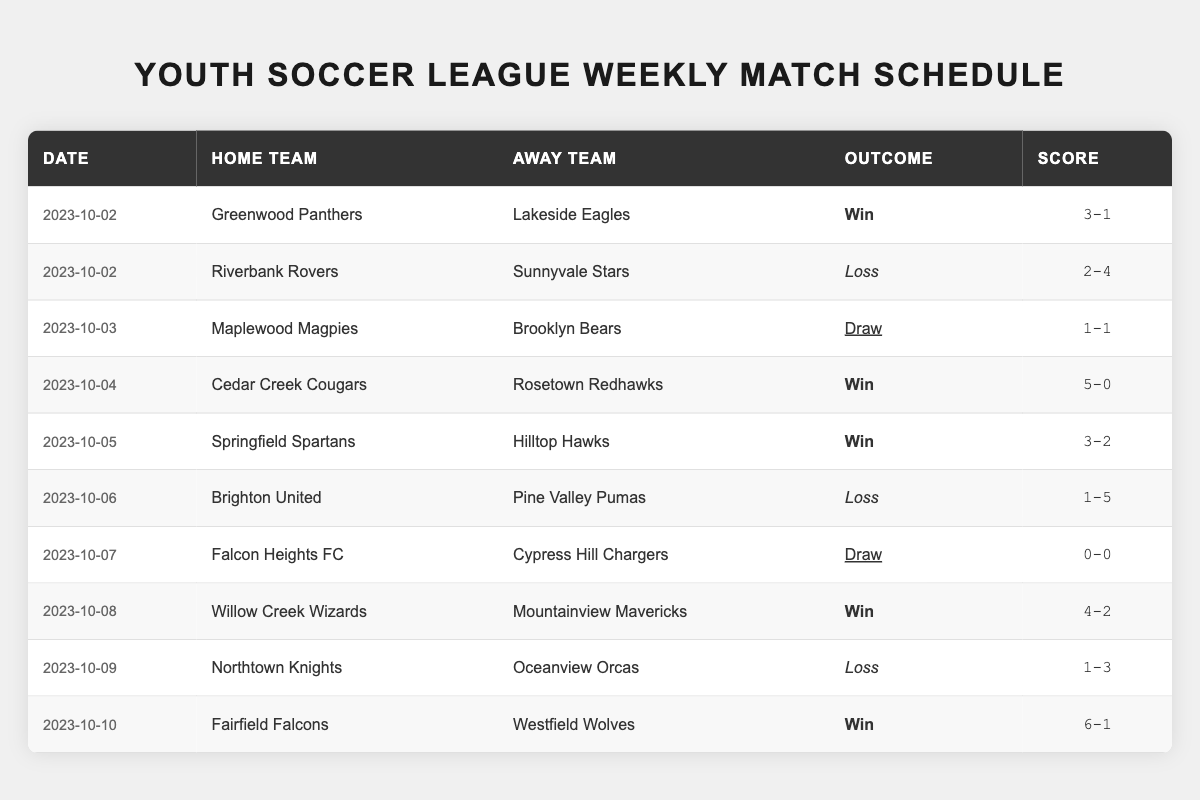What was the date when the Cedar Creek Cougars played against the Rosetown Redhawks? The match between Cedar Creek Cougars and Rosetown Redhawks is listed on the table under the date "2023-10-04."
Answer: 2023-10-04 How many matches did the Greenwood Panthers win? The table shows one match for Greenwood Panthers against Lakeside Eagles, which they won.
Answer: 1 What was the outcome of the game between the Falcon Heights FC and Cypress Hill Chargers? The table states that the Falcon Heights FC played against Cypress Hill Chargers and the outcome was a draw, with a score of "0-0."
Answer: Draw Which team scored the highest number of goals in a match? By reviewing the scores, Fairfield Falcons scored 6 goals in their match on "2023-10-10," which is the highest of any team.
Answer: Fairfield Falcons Did any teams end the week without a loss? Both Cedar Creek Cougars and Fairfield Falcons are the only teams to have won all their matches, hence they ended the week without a loss.
Answer: Yes What is the average score of the matches that ended in a win? First, identify the winning scores: (3-1, 5-0, 3-2, 4-2, 6-1). The total goals scored in wins is (3+5+3+4+6) = 21, and total goals conceded is (1+0+2+2+1) = 6. So, average goals for = 21/5 = 4.2, and average goals against = 6/5 = 1.2.
Answer: Average goals for: 4.2, Average goals against: 1.2 What was the result of the match between the Northtown Knights and the Oceanview Orcas? The table indicates that the Northtown Knights played against the Oceanview Orcas and the outcome was a loss for the Northtown Knights with a score of "1-3."
Answer: Loss for Northtown Knights How many matches resulted in a draw in total? The table includes two draws: one between Maplewood Magpies and Brooklyn Bears, and another between Falcon Heights FC and Cypress Hill Chargers.
Answer: 2 Which team scored more than 5 goals in their match? The only team that scored more than 5 goals is the Fairfield Falcons, who scored 6 goals against Westfield Wolves.
Answer: Fairfield Falcons What is the total score for matches that ended in a loss? The losses were: (2-4, 1-5, 1-3). Adding goals scored in losses gives (2+1+1) = 4, and goals conceded (4+5+3) = 12. Total score is 4-12 for matches that ended in a loss.
Answer: 4-12 Which team had the worst score margin in a game this week? The worst score margin occurred in the match where Brighton United lost to Pine Valley Pumas with a score of "1-5," resulting in a margin of 4 goals.
Answer: Brighton United 